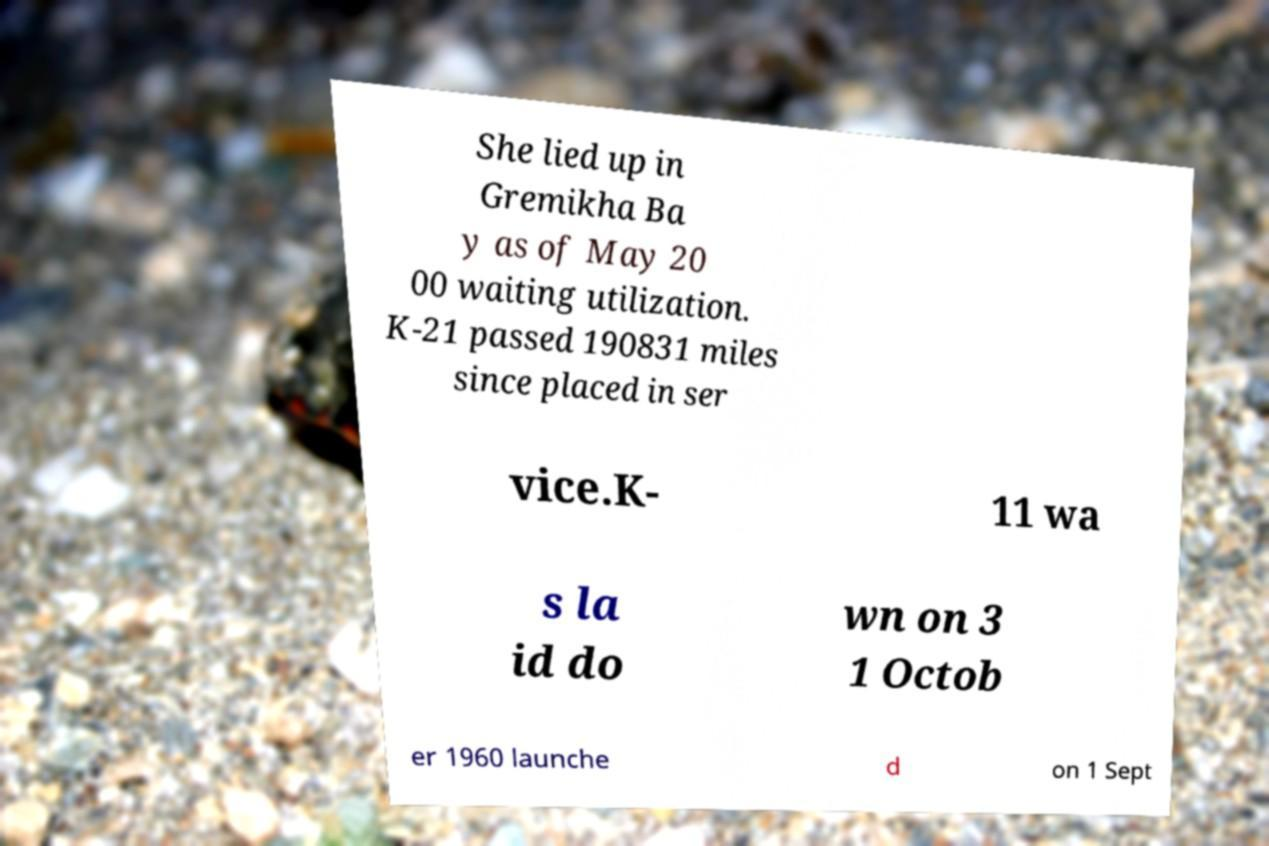Could you extract and type out the text from this image? She lied up in Gremikha Ba y as of May 20 00 waiting utilization. K-21 passed 190831 miles since placed in ser vice.K- 11 wa s la id do wn on 3 1 Octob er 1960 launche d on 1 Sept 